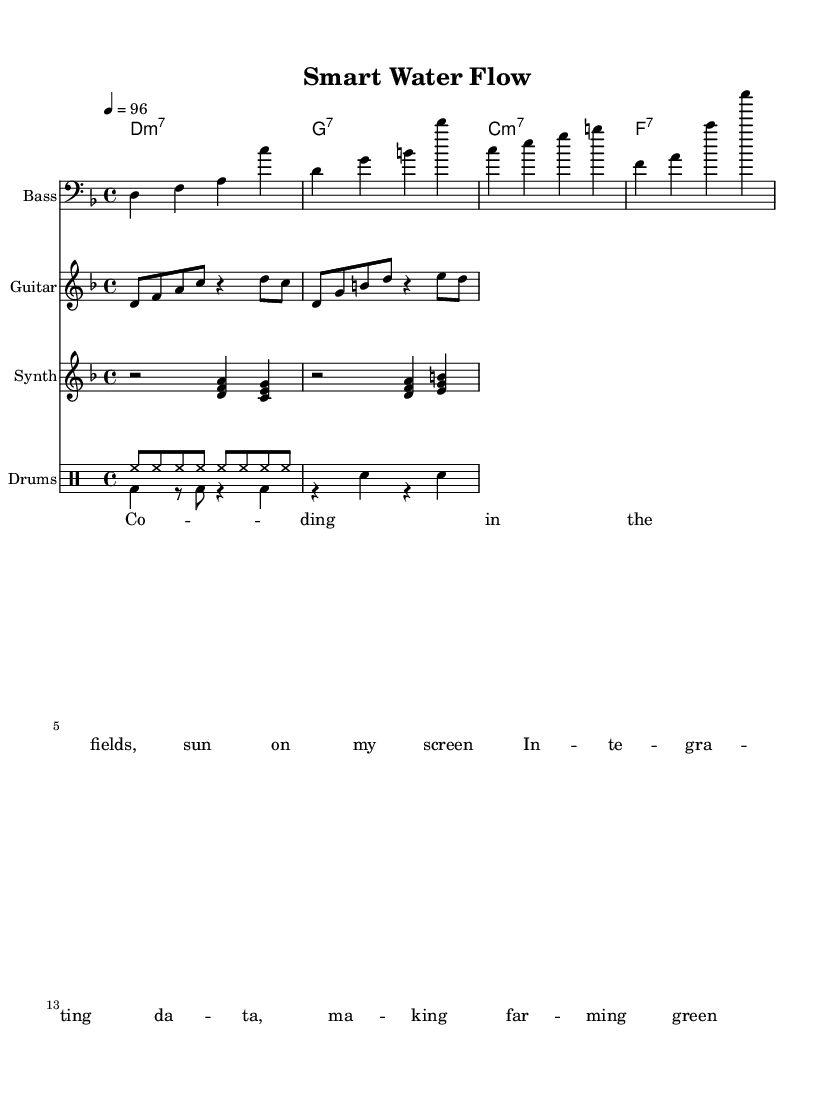What is the key signature of this music? The key signature is D minor, which has one flat (B flat). It is indicated at the beginning of the staff after the clef sign.
Answer: D minor What is the time signature? The time signature is 4/4, which means there are four beats per measure and the quarter note gets one beat. This is indicated at the beginning of the score.
Answer: 4/4 What is the tempo marking? The tempo marking is indicated as 4 equals 96, meaning there are 96 beats per minute. This guides the performance speed.
Answer: 96 How many measures are in the bass line? The bass line consists of 4 measures. Each horizontal segment separated by vertical lines represents a measure. Counting these gives a total of 4.
Answer: 4 What chords are used in this piece? The chords used are D minor 7, G 7, C minor 7, and F 7. They are listed at the top in the ChordNames section and define the harmonic structure.
Answer: D minor 7, G 7, C minor 7, F 7 What is the rhythmic pattern of the drum set? The drum pattern features a combination of hi-hat and bass drum hits, along with snare. It includes measures of 8 eighth notes followed by alternating bass and snare hits, which is typical in funk music.
Answer: hi-hat and bass drum pattern In which section of the music are the lyrics found? The lyrics are located at the bottom of the score, indicated by the Lyrics section, matching the rhythm of the music above. The lyrics describe themes related to smart farming and technology.
Answer: Lyrics section 